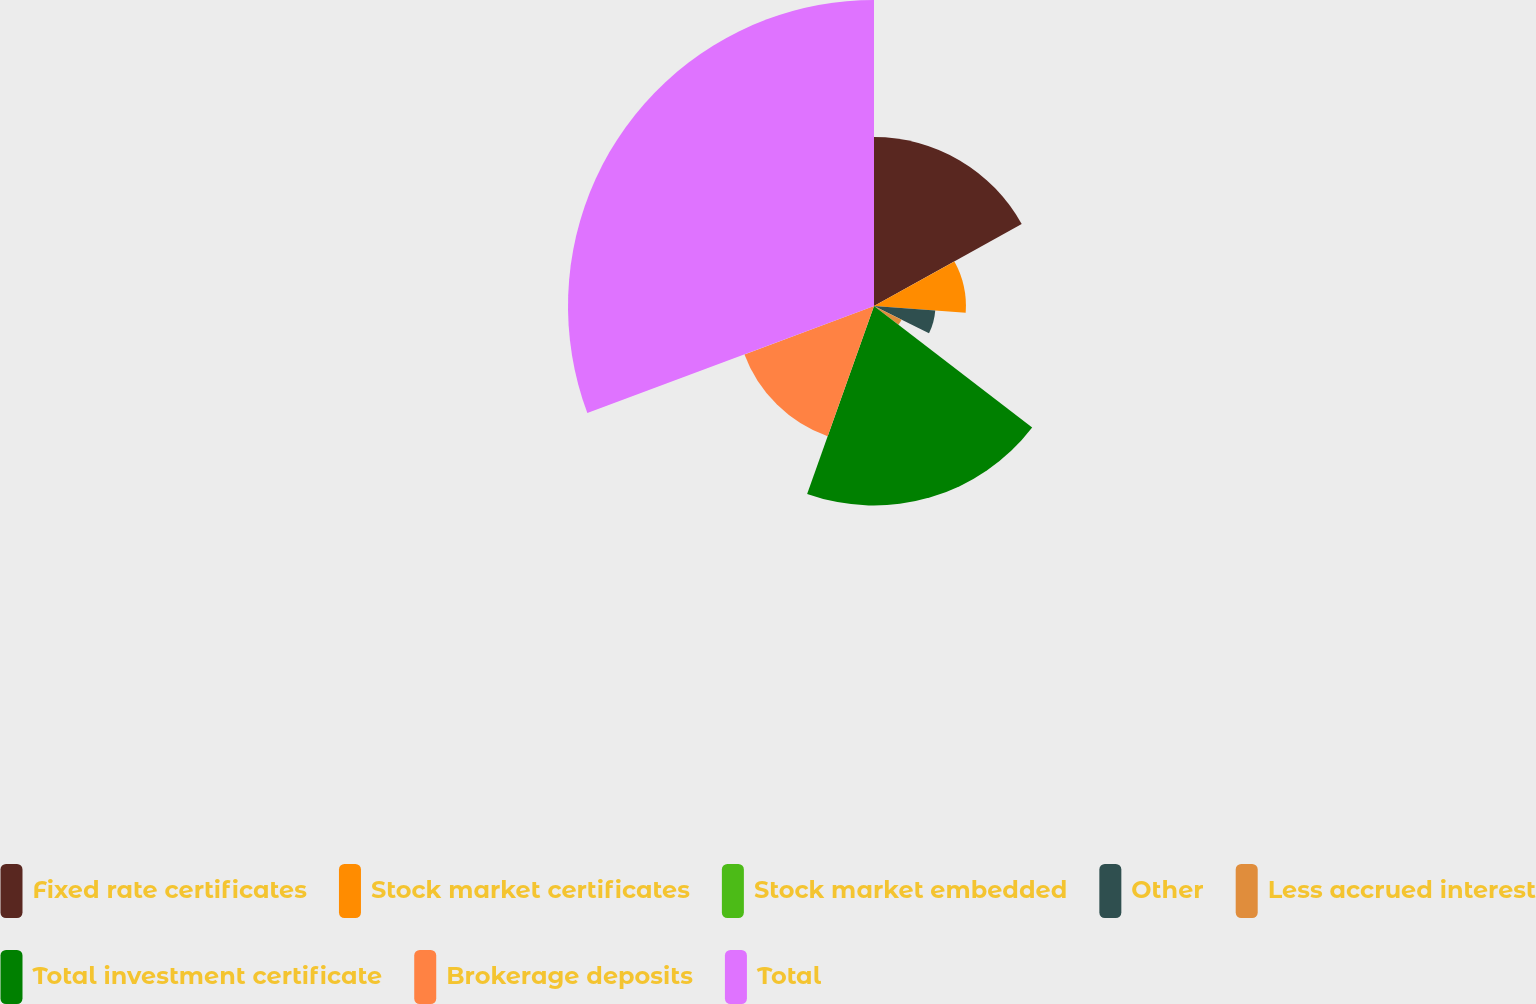Convert chart to OTSL. <chart><loc_0><loc_0><loc_500><loc_500><pie_chart><fcel>Fixed rate certificates<fcel>Stock market certificates<fcel>Stock market embedded<fcel>Other<fcel>Less accrued interest<fcel>Total investment certificate<fcel>Brokerage deposits<fcel>Total<nl><fcel>16.94%<fcel>9.22%<fcel>0.02%<fcel>6.16%<fcel>3.09%<fcel>20.01%<fcel>13.87%<fcel>30.69%<nl></chart> 